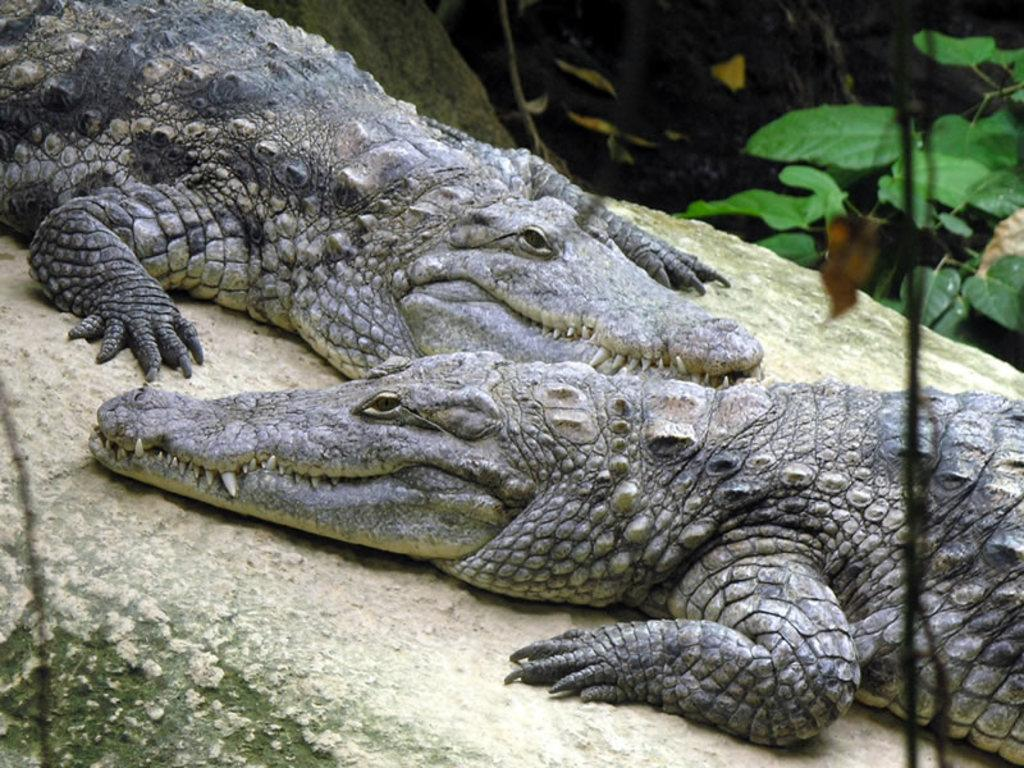How many crocodiles are in the image? There are two crocodiles in the image. What colors are the crocodiles in the image? The crocodiles are in black and ash color. What can be seen in the background of the image? There are plants visible in the background of the image. What type of tax is being discussed by the crocodiles in the image? There is no discussion or tax present in the image; it features two crocodiles and plants in the background. 